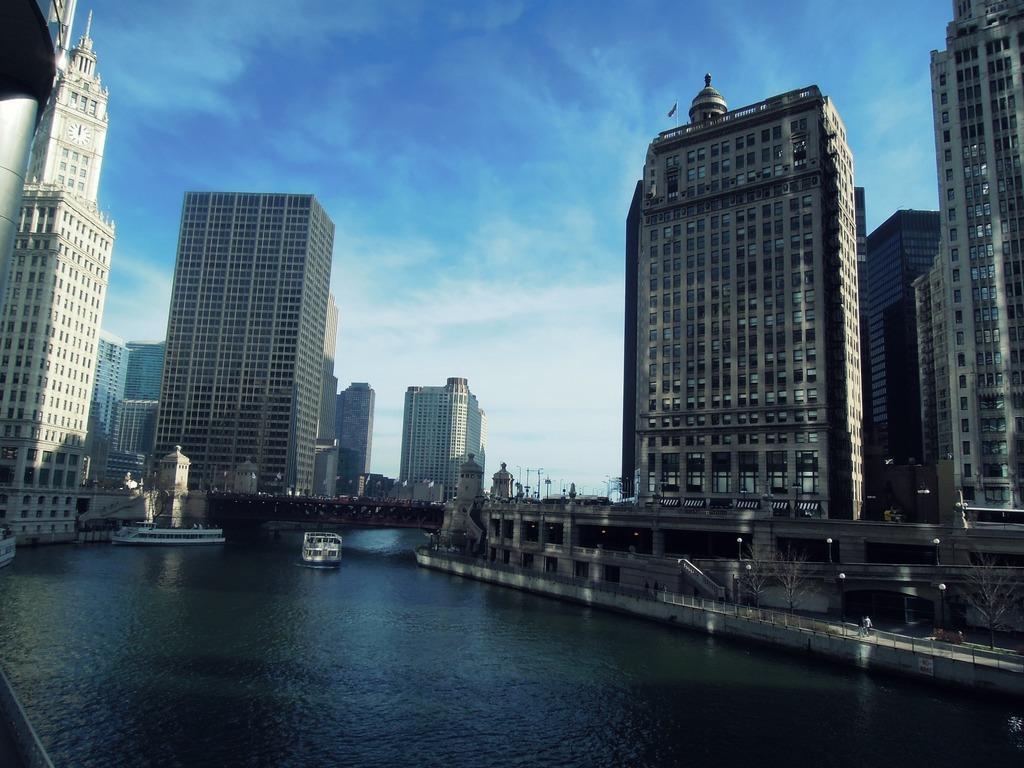Describe this image in one or two sentences. In this picture we can see buildings, bridge, boats, lights, some persons, water are there. At the top of the image clouds are present in the sky. 